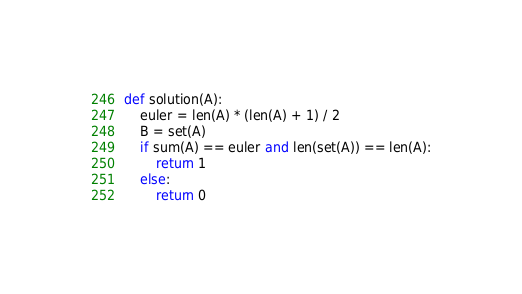Convert code to text. <code><loc_0><loc_0><loc_500><loc_500><_Python_>def solution(A):
    euler = len(A) * (len(A) + 1) / 2
    B = set(A)
    if sum(A) == euler and len(set(A)) == len(A):
        return 1
    else:
        return 0
</code> 